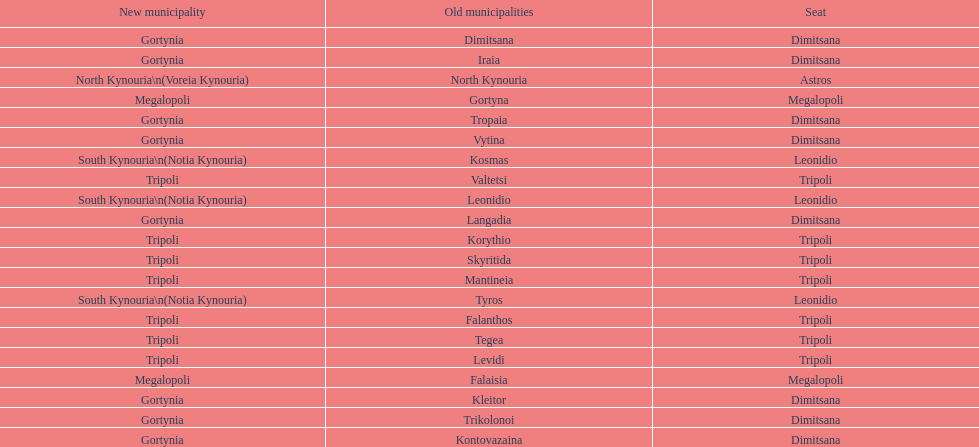What is the new municipality of tyros? South Kynouria. 